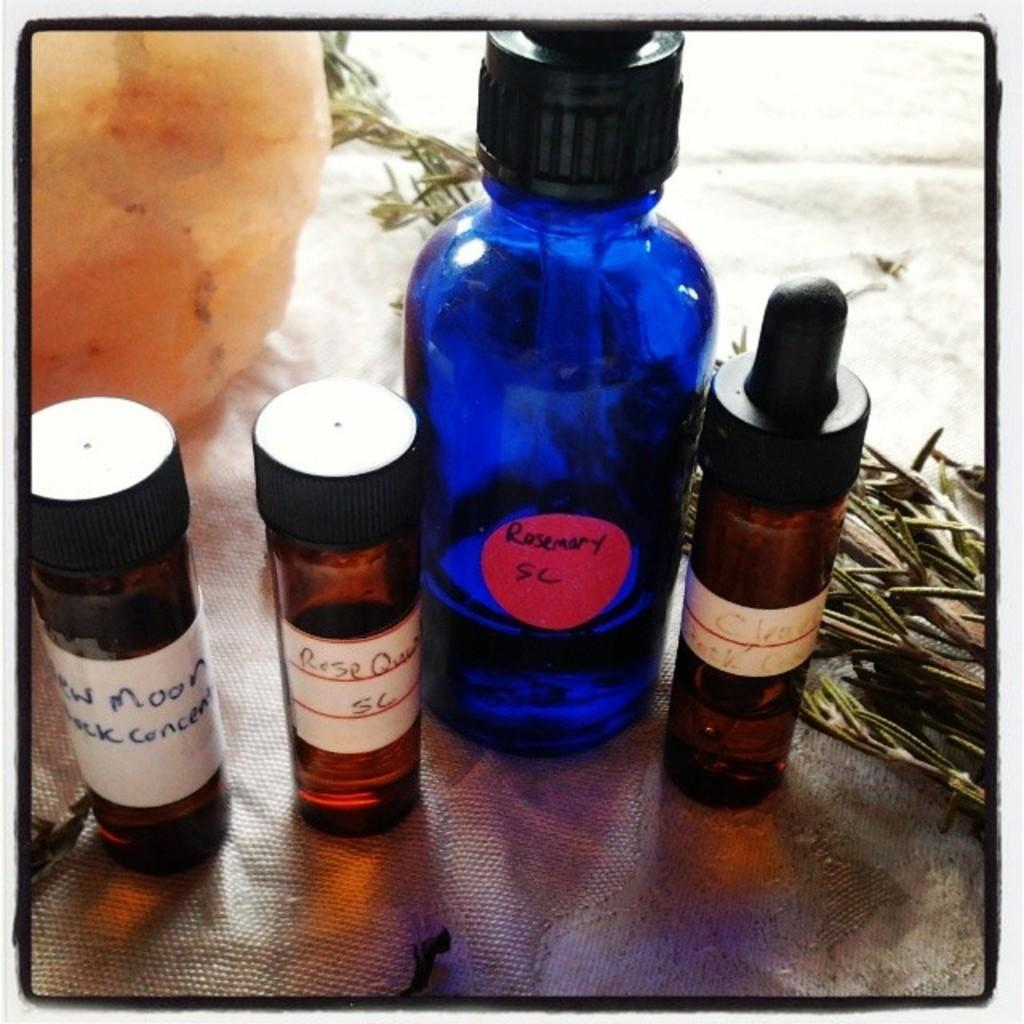<image>
Render a clear and concise summary of the photo. Four bottles on a table with handwritten notes including one that says "Rosemary SC" 